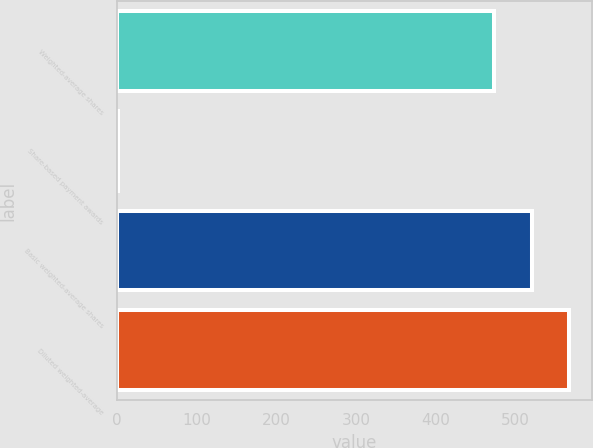Convert chart to OTSL. <chart><loc_0><loc_0><loc_500><loc_500><bar_chart><fcel>Weighted-average shares<fcel>Share-based payment awards<fcel>Basic weighted-average shares<fcel>Diluted weighted-average<nl><fcel>473.3<fcel>0.4<fcel>520.63<fcel>567.96<nl></chart> 